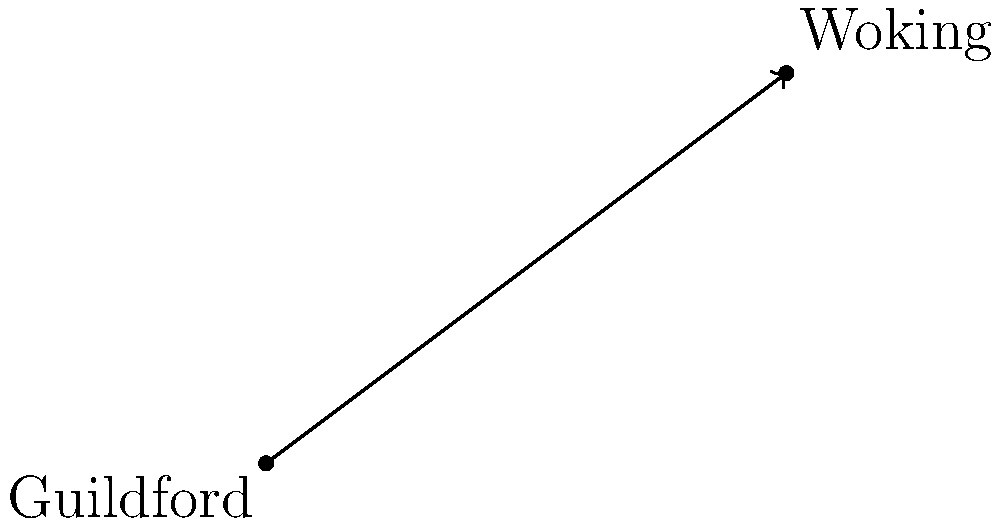A new straight road is being proposed to connect Guildford and Woking to improve public transportation. If Guildford is located at coordinates (0,0) and Woking is at (8,6) on a map grid where each unit represents 1 km, what is the equation of the line representing this new road? To find the equation of the line, we'll use the point-slope form of a line equation: $y - y_1 = m(x - x_1)$

Step 1: Calculate the slope (m) of the line.
$m = \frac{y_2 - y_1}{x_2 - x_1} = \frac{6 - 0}{8 - 0} = \frac{6}{8} = \frac{3}{4}$

Step 2: Use the point-slope form with the coordinates of Guildford (0,0).
$y - 0 = \frac{3}{4}(x - 0)$

Step 3: Simplify the equation.
$y = \frac{3}{4}x$

Therefore, the equation of the line representing the new road is $y = \frac{3}{4}x$.
Answer: $y = \frac{3}{4}x$ 